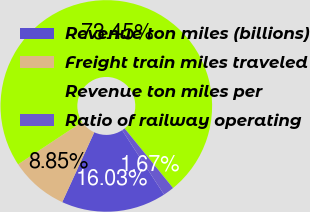Convert chart. <chart><loc_0><loc_0><loc_500><loc_500><pie_chart><fcel>Revenue ton miles (billions)<fcel>Freight train miles traveled<fcel>Revenue ton miles per<fcel>Ratio of railway operating<nl><fcel>16.03%<fcel>8.85%<fcel>73.45%<fcel>1.67%<nl></chart> 